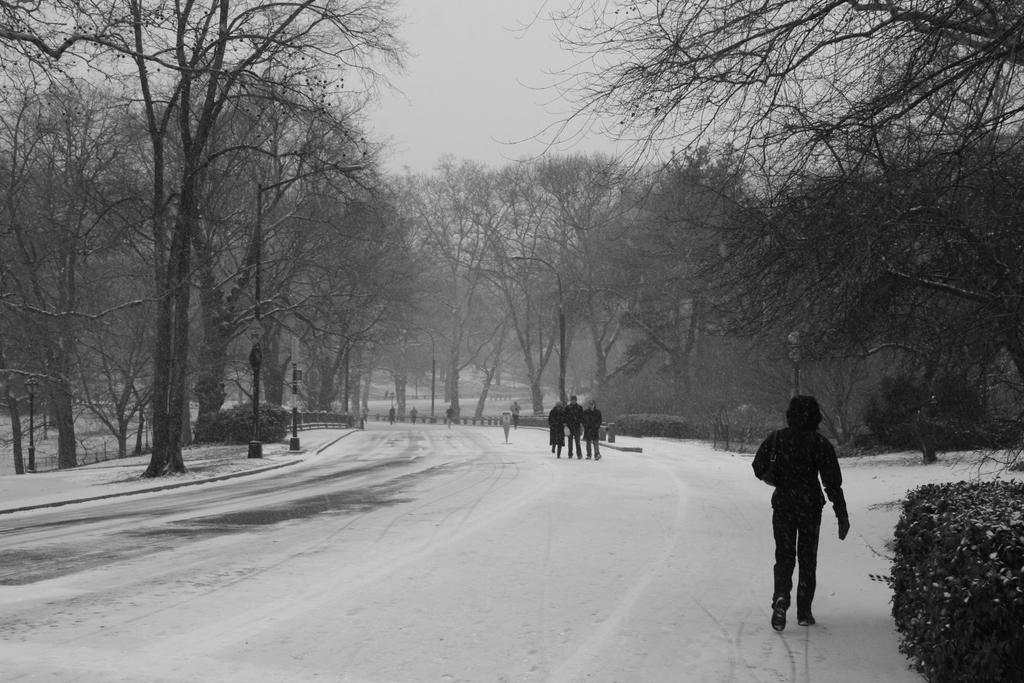What is the color scheme of the image? The image is black and white. What is the condition of the land in the image? The land is covered with snow. What are the people in the image doing? There are people walking on the snow-covered land. What type of vegetation is present in the area? There are many trees around the area. Can you tell me how many balloons are floating in the sky in the image? There are no balloons present in the image; it is a black and white image of people walking on snow-covered land with trees around the area. Is there a judge observing the people walking in the image? There is no judge present in the image; it only shows people walking on snow-covered land with trees around the area. 